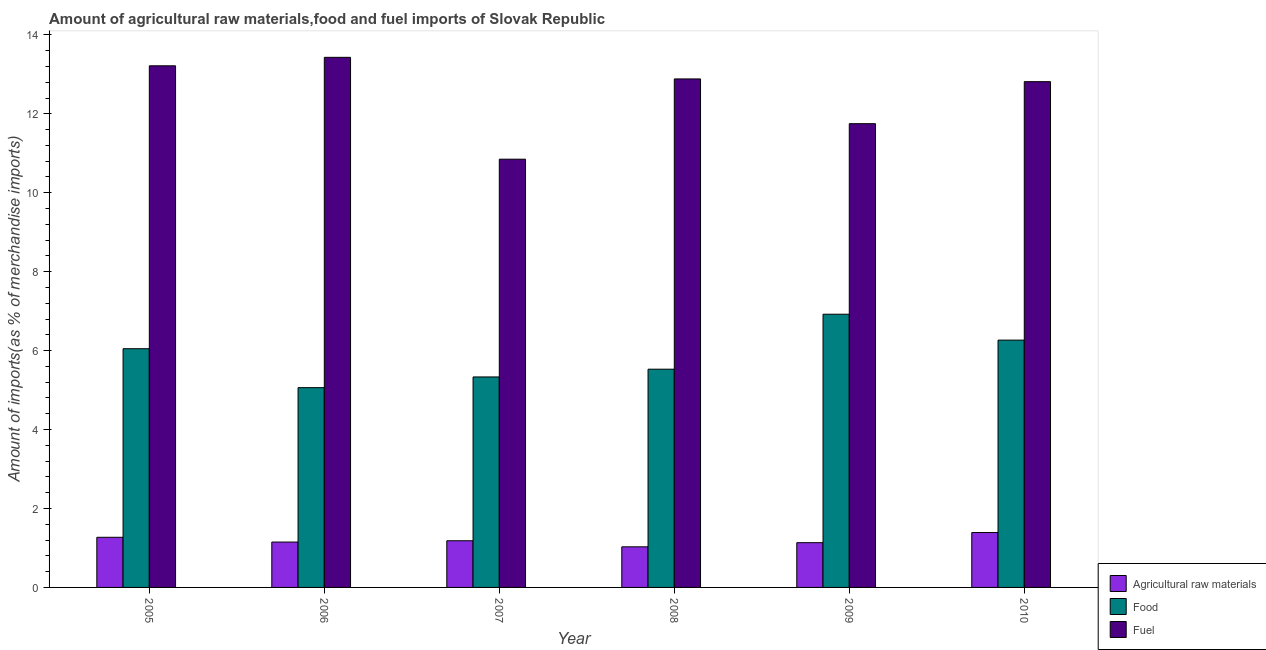How many groups of bars are there?
Offer a very short reply. 6. In how many cases, is the number of bars for a given year not equal to the number of legend labels?
Keep it short and to the point. 0. What is the percentage of raw materials imports in 2009?
Make the answer very short. 1.13. Across all years, what is the maximum percentage of fuel imports?
Your response must be concise. 13.43. Across all years, what is the minimum percentage of raw materials imports?
Ensure brevity in your answer.  1.03. In which year was the percentage of raw materials imports minimum?
Make the answer very short. 2008. What is the total percentage of raw materials imports in the graph?
Your answer should be compact. 7.16. What is the difference between the percentage of food imports in 2008 and that in 2010?
Provide a succinct answer. -0.74. What is the difference between the percentage of raw materials imports in 2009 and the percentage of fuel imports in 2005?
Provide a succinct answer. -0.14. What is the average percentage of fuel imports per year?
Offer a very short reply. 12.49. In the year 2007, what is the difference between the percentage of fuel imports and percentage of food imports?
Ensure brevity in your answer.  0. What is the ratio of the percentage of food imports in 2005 to that in 2007?
Ensure brevity in your answer.  1.13. Is the percentage of fuel imports in 2005 less than that in 2007?
Provide a short and direct response. No. Is the difference between the percentage of fuel imports in 2006 and 2007 greater than the difference between the percentage of raw materials imports in 2006 and 2007?
Keep it short and to the point. No. What is the difference between the highest and the second highest percentage of food imports?
Give a very brief answer. 0.66. What is the difference between the highest and the lowest percentage of food imports?
Provide a succinct answer. 1.86. What does the 3rd bar from the left in 2005 represents?
Provide a short and direct response. Fuel. What does the 1st bar from the right in 2010 represents?
Give a very brief answer. Fuel. How many bars are there?
Give a very brief answer. 18. What is the difference between two consecutive major ticks on the Y-axis?
Your answer should be very brief. 2. Are the values on the major ticks of Y-axis written in scientific E-notation?
Provide a short and direct response. No. Does the graph contain any zero values?
Your response must be concise. No. Does the graph contain grids?
Your response must be concise. No. Where does the legend appear in the graph?
Give a very brief answer. Bottom right. What is the title of the graph?
Provide a short and direct response. Amount of agricultural raw materials,food and fuel imports of Slovak Republic. What is the label or title of the X-axis?
Keep it short and to the point. Year. What is the label or title of the Y-axis?
Keep it short and to the point. Amount of imports(as % of merchandise imports). What is the Amount of imports(as % of merchandise imports) of Agricultural raw materials in 2005?
Give a very brief answer. 1.27. What is the Amount of imports(as % of merchandise imports) in Food in 2005?
Provide a succinct answer. 6.05. What is the Amount of imports(as % of merchandise imports) of Fuel in 2005?
Your answer should be compact. 13.22. What is the Amount of imports(as % of merchandise imports) in Agricultural raw materials in 2006?
Your answer should be very brief. 1.15. What is the Amount of imports(as % of merchandise imports) in Food in 2006?
Provide a succinct answer. 5.06. What is the Amount of imports(as % of merchandise imports) in Fuel in 2006?
Give a very brief answer. 13.43. What is the Amount of imports(as % of merchandise imports) of Agricultural raw materials in 2007?
Provide a succinct answer. 1.18. What is the Amount of imports(as % of merchandise imports) in Food in 2007?
Give a very brief answer. 5.33. What is the Amount of imports(as % of merchandise imports) in Fuel in 2007?
Offer a terse response. 10.85. What is the Amount of imports(as % of merchandise imports) of Agricultural raw materials in 2008?
Your response must be concise. 1.03. What is the Amount of imports(as % of merchandise imports) of Food in 2008?
Offer a very short reply. 5.53. What is the Amount of imports(as % of merchandise imports) of Fuel in 2008?
Provide a short and direct response. 12.88. What is the Amount of imports(as % of merchandise imports) of Agricultural raw materials in 2009?
Your answer should be very brief. 1.13. What is the Amount of imports(as % of merchandise imports) in Food in 2009?
Provide a short and direct response. 6.92. What is the Amount of imports(as % of merchandise imports) in Fuel in 2009?
Give a very brief answer. 11.75. What is the Amount of imports(as % of merchandise imports) in Agricultural raw materials in 2010?
Your answer should be compact. 1.39. What is the Amount of imports(as % of merchandise imports) in Food in 2010?
Offer a very short reply. 6.27. What is the Amount of imports(as % of merchandise imports) of Fuel in 2010?
Make the answer very short. 12.81. Across all years, what is the maximum Amount of imports(as % of merchandise imports) in Agricultural raw materials?
Your answer should be very brief. 1.39. Across all years, what is the maximum Amount of imports(as % of merchandise imports) in Food?
Ensure brevity in your answer.  6.92. Across all years, what is the maximum Amount of imports(as % of merchandise imports) in Fuel?
Ensure brevity in your answer.  13.43. Across all years, what is the minimum Amount of imports(as % of merchandise imports) of Agricultural raw materials?
Offer a very short reply. 1.03. Across all years, what is the minimum Amount of imports(as % of merchandise imports) in Food?
Provide a succinct answer. 5.06. Across all years, what is the minimum Amount of imports(as % of merchandise imports) in Fuel?
Offer a very short reply. 10.85. What is the total Amount of imports(as % of merchandise imports) in Agricultural raw materials in the graph?
Ensure brevity in your answer.  7.16. What is the total Amount of imports(as % of merchandise imports) in Food in the graph?
Make the answer very short. 35.16. What is the total Amount of imports(as % of merchandise imports) in Fuel in the graph?
Ensure brevity in your answer.  74.94. What is the difference between the Amount of imports(as % of merchandise imports) in Agricultural raw materials in 2005 and that in 2006?
Offer a very short reply. 0.12. What is the difference between the Amount of imports(as % of merchandise imports) of Food in 2005 and that in 2006?
Your answer should be very brief. 0.99. What is the difference between the Amount of imports(as % of merchandise imports) in Fuel in 2005 and that in 2006?
Ensure brevity in your answer.  -0.21. What is the difference between the Amount of imports(as % of merchandise imports) of Agricultural raw materials in 2005 and that in 2007?
Keep it short and to the point. 0.09. What is the difference between the Amount of imports(as % of merchandise imports) of Food in 2005 and that in 2007?
Make the answer very short. 0.72. What is the difference between the Amount of imports(as % of merchandise imports) of Fuel in 2005 and that in 2007?
Your answer should be compact. 2.37. What is the difference between the Amount of imports(as % of merchandise imports) in Agricultural raw materials in 2005 and that in 2008?
Make the answer very short. 0.24. What is the difference between the Amount of imports(as % of merchandise imports) of Food in 2005 and that in 2008?
Make the answer very short. 0.52. What is the difference between the Amount of imports(as % of merchandise imports) of Fuel in 2005 and that in 2008?
Make the answer very short. 0.33. What is the difference between the Amount of imports(as % of merchandise imports) in Agricultural raw materials in 2005 and that in 2009?
Provide a short and direct response. 0.14. What is the difference between the Amount of imports(as % of merchandise imports) of Food in 2005 and that in 2009?
Your response must be concise. -0.87. What is the difference between the Amount of imports(as % of merchandise imports) in Fuel in 2005 and that in 2009?
Make the answer very short. 1.47. What is the difference between the Amount of imports(as % of merchandise imports) of Agricultural raw materials in 2005 and that in 2010?
Offer a very short reply. -0.12. What is the difference between the Amount of imports(as % of merchandise imports) in Food in 2005 and that in 2010?
Ensure brevity in your answer.  -0.22. What is the difference between the Amount of imports(as % of merchandise imports) in Fuel in 2005 and that in 2010?
Make the answer very short. 0.4. What is the difference between the Amount of imports(as % of merchandise imports) of Agricultural raw materials in 2006 and that in 2007?
Give a very brief answer. -0.03. What is the difference between the Amount of imports(as % of merchandise imports) in Food in 2006 and that in 2007?
Your answer should be compact. -0.27. What is the difference between the Amount of imports(as % of merchandise imports) in Fuel in 2006 and that in 2007?
Ensure brevity in your answer.  2.58. What is the difference between the Amount of imports(as % of merchandise imports) of Agricultural raw materials in 2006 and that in 2008?
Make the answer very short. 0.12. What is the difference between the Amount of imports(as % of merchandise imports) in Food in 2006 and that in 2008?
Your answer should be compact. -0.47. What is the difference between the Amount of imports(as % of merchandise imports) in Fuel in 2006 and that in 2008?
Your answer should be compact. 0.55. What is the difference between the Amount of imports(as % of merchandise imports) of Agricultural raw materials in 2006 and that in 2009?
Your answer should be very brief. 0.02. What is the difference between the Amount of imports(as % of merchandise imports) of Food in 2006 and that in 2009?
Your answer should be compact. -1.86. What is the difference between the Amount of imports(as % of merchandise imports) in Fuel in 2006 and that in 2009?
Your response must be concise. 1.68. What is the difference between the Amount of imports(as % of merchandise imports) in Agricultural raw materials in 2006 and that in 2010?
Offer a very short reply. -0.24. What is the difference between the Amount of imports(as % of merchandise imports) of Food in 2006 and that in 2010?
Provide a succinct answer. -1.2. What is the difference between the Amount of imports(as % of merchandise imports) of Fuel in 2006 and that in 2010?
Your answer should be compact. 0.62. What is the difference between the Amount of imports(as % of merchandise imports) in Agricultural raw materials in 2007 and that in 2008?
Ensure brevity in your answer.  0.15. What is the difference between the Amount of imports(as % of merchandise imports) in Food in 2007 and that in 2008?
Give a very brief answer. -0.2. What is the difference between the Amount of imports(as % of merchandise imports) of Fuel in 2007 and that in 2008?
Make the answer very short. -2.03. What is the difference between the Amount of imports(as % of merchandise imports) in Agricultural raw materials in 2007 and that in 2009?
Make the answer very short. 0.05. What is the difference between the Amount of imports(as % of merchandise imports) of Food in 2007 and that in 2009?
Your response must be concise. -1.59. What is the difference between the Amount of imports(as % of merchandise imports) of Fuel in 2007 and that in 2009?
Keep it short and to the point. -0.9. What is the difference between the Amount of imports(as % of merchandise imports) in Agricultural raw materials in 2007 and that in 2010?
Provide a succinct answer. -0.21. What is the difference between the Amount of imports(as % of merchandise imports) of Food in 2007 and that in 2010?
Provide a short and direct response. -0.93. What is the difference between the Amount of imports(as % of merchandise imports) of Fuel in 2007 and that in 2010?
Provide a short and direct response. -1.96. What is the difference between the Amount of imports(as % of merchandise imports) of Agricultural raw materials in 2008 and that in 2009?
Your answer should be very brief. -0.11. What is the difference between the Amount of imports(as % of merchandise imports) of Food in 2008 and that in 2009?
Your answer should be compact. -1.39. What is the difference between the Amount of imports(as % of merchandise imports) in Fuel in 2008 and that in 2009?
Provide a short and direct response. 1.13. What is the difference between the Amount of imports(as % of merchandise imports) in Agricultural raw materials in 2008 and that in 2010?
Your answer should be compact. -0.36. What is the difference between the Amount of imports(as % of merchandise imports) of Food in 2008 and that in 2010?
Keep it short and to the point. -0.74. What is the difference between the Amount of imports(as % of merchandise imports) of Fuel in 2008 and that in 2010?
Provide a succinct answer. 0.07. What is the difference between the Amount of imports(as % of merchandise imports) in Agricultural raw materials in 2009 and that in 2010?
Make the answer very short. -0.26. What is the difference between the Amount of imports(as % of merchandise imports) of Food in 2009 and that in 2010?
Give a very brief answer. 0.66. What is the difference between the Amount of imports(as % of merchandise imports) in Fuel in 2009 and that in 2010?
Your response must be concise. -1.06. What is the difference between the Amount of imports(as % of merchandise imports) in Agricultural raw materials in 2005 and the Amount of imports(as % of merchandise imports) in Food in 2006?
Offer a very short reply. -3.79. What is the difference between the Amount of imports(as % of merchandise imports) in Agricultural raw materials in 2005 and the Amount of imports(as % of merchandise imports) in Fuel in 2006?
Your answer should be compact. -12.16. What is the difference between the Amount of imports(as % of merchandise imports) in Food in 2005 and the Amount of imports(as % of merchandise imports) in Fuel in 2006?
Make the answer very short. -7.38. What is the difference between the Amount of imports(as % of merchandise imports) in Agricultural raw materials in 2005 and the Amount of imports(as % of merchandise imports) in Food in 2007?
Provide a short and direct response. -4.06. What is the difference between the Amount of imports(as % of merchandise imports) of Agricultural raw materials in 2005 and the Amount of imports(as % of merchandise imports) of Fuel in 2007?
Ensure brevity in your answer.  -9.58. What is the difference between the Amount of imports(as % of merchandise imports) in Food in 2005 and the Amount of imports(as % of merchandise imports) in Fuel in 2007?
Make the answer very short. -4.8. What is the difference between the Amount of imports(as % of merchandise imports) in Agricultural raw materials in 2005 and the Amount of imports(as % of merchandise imports) in Food in 2008?
Offer a very short reply. -4.26. What is the difference between the Amount of imports(as % of merchandise imports) of Agricultural raw materials in 2005 and the Amount of imports(as % of merchandise imports) of Fuel in 2008?
Offer a very short reply. -11.61. What is the difference between the Amount of imports(as % of merchandise imports) in Food in 2005 and the Amount of imports(as % of merchandise imports) in Fuel in 2008?
Offer a very short reply. -6.84. What is the difference between the Amount of imports(as % of merchandise imports) of Agricultural raw materials in 2005 and the Amount of imports(as % of merchandise imports) of Food in 2009?
Provide a short and direct response. -5.65. What is the difference between the Amount of imports(as % of merchandise imports) in Agricultural raw materials in 2005 and the Amount of imports(as % of merchandise imports) in Fuel in 2009?
Provide a succinct answer. -10.48. What is the difference between the Amount of imports(as % of merchandise imports) of Food in 2005 and the Amount of imports(as % of merchandise imports) of Fuel in 2009?
Offer a very short reply. -5.7. What is the difference between the Amount of imports(as % of merchandise imports) in Agricultural raw materials in 2005 and the Amount of imports(as % of merchandise imports) in Food in 2010?
Offer a very short reply. -5. What is the difference between the Amount of imports(as % of merchandise imports) in Agricultural raw materials in 2005 and the Amount of imports(as % of merchandise imports) in Fuel in 2010?
Give a very brief answer. -11.54. What is the difference between the Amount of imports(as % of merchandise imports) of Food in 2005 and the Amount of imports(as % of merchandise imports) of Fuel in 2010?
Offer a very short reply. -6.77. What is the difference between the Amount of imports(as % of merchandise imports) in Agricultural raw materials in 2006 and the Amount of imports(as % of merchandise imports) in Food in 2007?
Your answer should be very brief. -4.18. What is the difference between the Amount of imports(as % of merchandise imports) in Agricultural raw materials in 2006 and the Amount of imports(as % of merchandise imports) in Fuel in 2007?
Your answer should be very brief. -9.7. What is the difference between the Amount of imports(as % of merchandise imports) of Food in 2006 and the Amount of imports(as % of merchandise imports) of Fuel in 2007?
Your answer should be very brief. -5.79. What is the difference between the Amount of imports(as % of merchandise imports) in Agricultural raw materials in 2006 and the Amount of imports(as % of merchandise imports) in Food in 2008?
Your answer should be compact. -4.38. What is the difference between the Amount of imports(as % of merchandise imports) of Agricultural raw materials in 2006 and the Amount of imports(as % of merchandise imports) of Fuel in 2008?
Keep it short and to the point. -11.73. What is the difference between the Amount of imports(as % of merchandise imports) of Food in 2006 and the Amount of imports(as % of merchandise imports) of Fuel in 2008?
Your answer should be compact. -7.82. What is the difference between the Amount of imports(as % of merchandise imports) in Agricultural raw materials in 2006 and the Amount of imports(as % of merchandise imports) in Food in 2009?
Provide a succinct answer. -5.77. What is the difference between the Amount of imports(as % of merchandise imports) of Food in 2006 and the Amount of imports(as % of merchandise imports) of Fuel in 2009?
Give a very brief answer. -6.69. What is the difference between the Amount of imports(as % of merchandise imports) in Agricultural raw materials in 2006 and the Amount of imports(as % of merchandise imports) in Food in 2010?
Provide a short and direct response. -5.12. What is the difference between the Amount of imports(as % of merchandise imports) of Agricultural raw materials in 2006 and the Amount of imports(as % of merchandise imports) of Fuel in 2010?
Provide a short and direct response. -11.66. What is the difference between the Amount of imports(as % of merchandise imports) of Food in 2006 and the Amount of imports(as % of merchandise imports) of Fuel in 2010?
Your answer should be very brief. -7.75. What is the difference between the Amount of imports(as % of merchandise imports) of Agricultural raw materials in 2007 and the Amount of imports(as % of merchandise imports) of Food in 2008?
Ensure brevity in your answer.  -4.35. What is the difference between the Amount of imports(as % of merchandise imports) of Agricultural raw materials in 2007 and the Amount of imports(as % of merchandise imports) of Fuel in 2008?
Your response must be concise. -11.7. What is the difference between the Amount of imports(as % of merchandise imports) in Food in 2007 and the Amount of imports(as % of merchandise imports) in Fuel in 2008?
Your response must be concise. -7.55. What is the difference between the Amount of imports(as % of merchandise imports) of Agricultural raw materials in 2007 and the Amount of imports(as % of merchandise imports) of Food in 2009?
Ensure brevity in your answer.  -5.74. What is the difference between the Amount of imports(as % of merchandise imports) in Agricultural raw materials in 2007 and the Amount of imports(as % of merchandise imports) in Fuel in 2009?
Your answer should be very brief. -10.57. What is the difference between the Amount of imports(as % of merchandise imports) of Food in 2007 and the Amount of imports(as % of merchandise imports) of Fuel in 2009?
Give a very brief answer. -6.42. What is the difference between the Amount of imports(as % of merchandise imports) of Agricultural raw materials in 2007 and the Amount of imports(as % of merchandise imports) of Food in 2010?
Keep it short and to the point. -5.08. What is the difference between the Amount of imports(as % of merchandise imports) in Agricultural raw materials in 2007 and the Amount of imports(as % of merchandise imports) in Fuel in 2010?
Make the answer very short. -11.63. What is the difference between the Amount of imports(as % of merchandise imports) in Food in 2007 and the Amount of imports(as % of merchandise imports) in Fuel in 2010?
Ensure brevity in your answer.  -7.48. What is the difference between the Amount of imports(as % of merchandise imports) of Agricultural raw materials in 2008 and the Amount of imports(as % of merchandise imports) of Food in 2009?
Give a very brief answer. -5.89. What is the difference between the Amount of imports(as % of merchandise imports) of Agricultural raw materials in 2008 and the Amount of imports(as % of merchandise imports) of Fuel in 2009?
Your answer should be compact. -10.72. What is the difference between the Amount of imports(as % of merchandise imports) of Food in 2008 and the Amount of imports(as % of merchandise imports) of Fuel in 2009?
Provide a succinct answer. -6.22. What is the difference between the Amount of imports(as % of merchandise imports) in Agricultural raw materials in 2008 and the Amount of imports(as % of merchandise imports) in Food in 2010?
Ensure brevity in your answer.  -5.24. What is the difference between the Amount of imports(as % of merchandise imports) of Agricultural raw materials in 2008 and the Amount of imports(as % of merchandise imports) of Fuel in 2010?
Keep it short and to the point. -11.79. What is the difference between the Amount of imports(as % of merchandise imports) in Food in 2008 and the Amount of imports(as % of merchandise imports) in Fuel in 2010?
Keep it short and to the point. -7.28. What is the difference between the Amount of imports(as % of merchandise imports) in Agricultural raw materials in 2009 and the Amount of imports(as % of merchandise imports) in Food in 2010?
Give a very brief answer. -5.13. What is the difference between the Amount of imports(as % of merchandise imports) in Agricultural raw materials in 2009 and the Amount of imports(as % of merchandise imports) in Fuel in 2010?
Provide a succinct answer. -11.68. What is the difference between the Amount of imports(as % of merchandise imports) in Food in 2009 and the Amount of imports(as % of merchandise imports) in Fuel in 2010?
Make the answer very short. -5.89. What is the average Amount of imports(as % of merchandise imports) of Agricultural raw materials per year?
Provide a short and direct response. 1.19. What is the average Amount of imports(as % of merchandise imports) in Food per year?
Offer a very short reply. 5.86. What is the average Amount of imports(as % of merchandise imports) of Fuel per year?
Make the answer very short. 12.49. In the year 2005, what is the difference between the Amount of imports(as % of merchandise imports) of Agricultural raw materials and Amount of imports(as % of merchandise imports) of Food?
Keep it short and to the point. -4.78. In the year 2005, what is the difference between the Amount of imports(as % of merchandise imports) of Agricultural raw materials and Amount of imports(as % of merchandise imports) of Fuel?
Ensure brevity in your answer.  -11.95. In the year 2005, what is the difference between the Amount of imports(as % of merchandise imports) of Food and Amount of imports(as % of merchandise imports) of Fuel?
Provide a short and direct response. -7.17. In the year 2006, what is the difference between the Amount of imports(as % of merchandise imports) in Agricultural raw materials and Amount of imports(as % of merchandise imports) in Food?
Offer a terse response. -3.91. In the year 2006, what is the difference between the Amount of imports(as % of merchandise imports) in Agricultural raw materials and Amount of imports(as % of merchandise imports) in Fuel?
Provide a short and direct response. -12.28. In the year 2006, what is the difference between the Amount of imports(as % of merchandise imports) in Food and Amount of imports(as % of merchandise imports) in Fuel?
Offer a terse response. -8.37. In the year 2007, what is the difference between the Amount of imports(as % of merchandise imports) of Agricultural raw materials and Amount of imports(as % of merchandise imports) of Food?
Give a very brief answer. -4.15. In the year 2007, what is the difference between the Amount of imports(as % of merchandise imports) in Agricultural raw materials and Amount of imports(as % of merchandise imports) in Fuel?
Give a very brief answer. -9.67. In the year 2007, what is the difference between the Amount of imports(as % of merchandise imports) in Food and Amount of imports(as % of merchandise imports) in Fuel?
Provide a succinct answer. -5.52. In the year 2008, what is the difference between the Amount of imports(as % of merchandise imports) in Agricultural raw materials and Amount of imports(as % of merchandise imports) in Food?
Give a very brief answer. -4.5. In the year 2008, what is the difference between the Amount of imports(as % of merchandise imports) in Agricultural raw materials and Amount of imports(as % of merchandise imports) in Fuel?
Your response must be concise. -11.85. In the year 2008, what is the difference between the Amount of imports(as % of merchandise imports) in Food and Amount of imports(as % of merchandise imports) in Fuel?
Provide a succinct answer. -7.35. In the year 2009, what is the difference between the Amount of imports(as % of merchandise imports) in Agricultural raw materials and Amount of imports(as % of merchandise imports) in Food?
Your answer should be very brief. -5.79. In the year 2009, what is the difference between the Amount of imports(as % of merchandise imports) of Agricultural raw materials and Amount of imports(as % of merchandise imports) of Fuel?
Keep it short and to the point. -10.62. In the year 2009, what is the difference between the Amount of imports(as % of merchandise imports) in Food and Amount of imports(as % of merchandise imports) in Fuel?
Your answer should be compact. -4.83. In the year 2010, what is the difference between the Amount of imports(as % of merchandise imports) in Agricultural raw materials and Amount of imports(as % of merchandise imports) in Food?
Provide a succinct answer. -4.88. In the year 2010, what is the difference between the Amount of imports(as % of merchandise imports) in Agricultural raw materials and Amount of imports(as % of merchandise imports) in Fuel?
Your answer should be compact. -11.42. In the year 2010, what is the difference between the Amount of imports(as % of merchandise imports) in Food and Amount of imports(as % of merchandise imports) in Fuel?
Make the answer very short. -6.55. What is the ratio of the Amount of imports(as % of merchandise imports) of Agricultural raw materials in 2005 to that in 2006?
Provide a succinct answer. 1.11. What is the ratio of the Amount of imports(as % of merchandise imports) in Food in 2005 to that in 2006?
Provide a succinct answer. 1.19. What is the ratio of the Amount of imports(as % of merchandise imports) in Agricultural raw materials in 2005 to that in 2007?
Your answer should be very brief. 1.07. What is the ratio of the Amount of imports(as % of merchandise imports) of Food in 2005 to that in 2007?
Ensure brevity in your answer.  1.13. What is the ratio of the Amount of imports(as % of merchandise imports) in Fuel in 2005 to that in 2007?
Offer a very short reply. 1.22. What is the ratio of the Amount of imports(as % of merchandise imports) in Agricultural raw materials in 2005 to that in 2008?
Your answer should be very brief. 1.24. What is the ratio of the Amount of imports(as % of merchandise imports) of Food in 2005 to that in 2008?
Offer a terse response. 1.09. What is the ratio of the Amount of imports(as % of merchandise imports) of Fuel in 2005 to that in 2008?
Ensure brevity in your answer.  1.03. What is the ratio of the Amount of imports(as % of merchandise imports) of Agricultural raw materials in 2005 to that in 2009?
Offer a terse response. 1.12. What is the ratio of the Amount of imports(as % of merchandise imports) of Food in 2005 to that in 2009?
Your response must be concise. 0.87. What is the ratio of the Amount of imports(as % of merchandise imports) of Fuel in 2005 to that in 2009?
Offer a terse response. 1.12. What is the ratio of the Amount of imports(as % of merchandise imports) in Agricultural raw materials in 2005 to that in 2010?
Provide a short and direct response. 0.91. What is the ratio of the Amount of imports(as % of merchandise imports) of Food in 2005 to that in 2010?
Provide a succinct answer. 0.97. What is the ratio of the Amount of imports(as % of merchandise imports) of Fuel in 2005 to that in 2010?
Offer a very short reply. 1.03. What is the ratio of the Amount of imports(as % of merchandise imports) in Agricultural raw materials in 2006 to that in 2007?
Your response must be concise. 0.97. What is the ratio of the Amount of imports(as % of merchandise imports) in Food in 2006 to that in 2007?
Provide a succinct answer. 0.95. What is the ratio of the Amount of imports(as % of merchandise imports) of Fuel in 2006 to that in 2007?
Make the answer very short. 1.24. What is the ratio of the Amount of imports(as % of merchandise imports) of Agricultural raw materials in 2006 to that in 2008?
Make the answer very short. 1.12. What is the ratio of the Amount of imports(as % of merchandise imports) in Food in 2006 to that in 2008?
Provide a short and direct response. 0.92. What is the ratio of the Amount of imports(as % of merchandise imports) of Fuel in 2006 to that in 2008?
Ensure brevity in your answer.  1.04. What is the ratio of the Amount of imports(as % of merchandise imports) of Agricultural raw materials in 2006 to that in 2009?
Offer a terse response. 1.01. What is the ratio of the Amount of imports(as % of merchandise imports) in Food in 2006 to that in 2009?
Your answer should be compact. 0.73. What is the ratio of the Amount of imports(as % of merchandise imports) in Fuel in 2006 to that in 2009?
Keep it short and to the point. 1.14. What is the ratio of the Amount of imports(as % of merchandise imports) in Agricultural raw materials in 2006 to that in 2010?
Ensure brevity in your answer.  0.83. What is the ratio of the Amount of imports(as % of merchandise imports) of Food in 2006 to that in 2010?
Provide a succinct answer. 0.81. What is the ratio of the Amount of imports(as % of merchandise imports) of Fuel in 2006 to that in 2010?
Give a very brief answer. 1.05. What is the ratio of the Amount of imports(as % of merchandise imports) in Agricultural raw materials in 2007 to that in 2008?
Your answer should be very brief. 1.15. What is the ratio of the Amount of imports(as % of merchandise imports) in Food in 2007 to that in 2008?
Your answer should be very brief. 0.96. What is the ratio of the Amount of imports(as % of merchandise imports) in Fuel in 2007 to that in 2008?
Keep it short and to the point. 0.84. What is the ratio of the Amount of imports(as % of merchandise imports) of Agricultural raw materials in 2007 to that in 2009?
Your response must be concise. 1.04. What is the ratio of the Amount of imports(as % of merchandise imports) of Food in 2007 to that in 2009?
Your answer should be compact. 0.77. What is the ratio of the Amount of imports(as % of merchandise imports) in Fuel in 2007 to that in 2009?
Make the answer very short. 0.92. What is the ratio of the Amount of imports(as % of merchandise imports) of Agricultural raw materials in 2007 to that in 2010?
Provide a succinct answer. 0.85. What is the ratio of the Amount of imports(as % of merchandise imports) of Food in 2007 to that in 2010?
Your response must be concise. 0.85. What is the ratio of the Amount of imports(as % of merchandise imports) in Fuel in 2007 to that in 2010?
Make the answer very short. 0.85. What is the ratio of the Amount of imports(as % of merchandise imports) of Agricultural raw materials in 2008 to that in 2009?
Your answer should be very brief. 0.91. What is the ratio of the Amount of imports(as % of merchandise imports) of Food in 2008 to that in 2009?
Provide a succinct answer. 0.8. What is the ratio of the Amount of imports(as % of merchandise imports) of Fuel in 2008 to that in 2009?
Your answer should be compact. 1.1. What is the ratio of the Amount of imports(as % of merchandise imports) of Agricultural raw materials in 2008 to that in 2010?
Your response must be concise. 0.74. What is the ratio of the Amount of imports(as % of merchandise imports) in Food in 2008 to that in 2010?
Your answer should be compact. 0.88. What is the ratio of the Amount of imports(as % of merchandise imports) in Fuel in 2008 to that in 2010?
Your answer should be compact. 1.01. What is the ratio of the Amount of imports(as % of merchandise imports) in Agricultural raw materials in 2009 to that in 2010?
Your answer should be very brief. 0.82. What is the ratio of the Amount of imports(as % of merchandise imports) of Food in 2009 to that in 2010?
Provide a short and direct response. 1.1. What is the ratio of the Amount of imports(as % of merchandise imports) in Fuel in 2009 to that in 2010?
Offer a very short reply. 0.92. What is the difference between the highest and the second highest Amount of imports(as % of merchandise imports) of Agricultural raw materials?
Ensure brevity in your answer.  0.12. What is the difference between the highest and the second highest Amount of imports(as % of merchandise imports) of Food?
Give a very brief answer. 0.66. What is the difference between the highest and the second highest Amount of imports(as % of merchandise imports) in Fuel?
Give a very brief answer. 0.21. What is the difference between the highest and the lowest Amount of imports(as % of merchandise imports) in Agricultural raw materials?
Ensure brevity in your answer.  0.36. What is the difference between the highest and the lowest Amount of imports(as % of merchandise imports) in Food?
Give a very brief answer. 1.86. What is the difference between the highest and the lowest Amount of imports(as % of merchandise imports) of Fuel?
Ensure brevity in your answer.  2.58. 